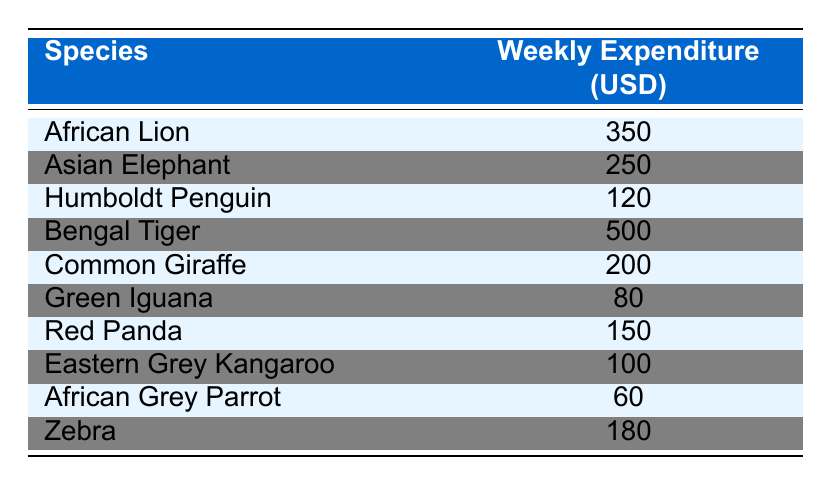What is the weekly expenditure for a Bengal Tiger? The table shows a specific expenditure for each species. Looking at the row for Bengal Tiger, the weekly expenditure is listed as 500 USD.
Answer: 500 USD Which species has the lowest weekly expenditure? To find the lowest expenditure, we can compare the values in the table. The Green Iguana has the lowest amount listed at 80 USD.
Answer: Green Iguana What is the total weekly expenditure for all species combined? To find the total, we sum up the weekly expenditures from all species: 350 + 250 + 120 + 500 + 200 + 80 + 150 + 100 + 60 + 180 = 1990 USD.
Answer: 1990 USD Is the weekly expenditure for an African Grey Parrot greater than 70 USD? The weekly expenditure for an African Grey Parrot is listed as 60 USD, which is less than 70 USD.
Answer: No What is the average weekly expenditure for the exotic species (African Lion, Bengal Tiger, Red Panda, and Humboldt Penguin)? To find the average, first sum the weekly expenditures for these four species (350 + 500 + 150 + 120 = 1120 USD) and then divide by the number of species (4). So, the average is 1120/4 = 280 USD.
Answer: 280 USD How much more does the weekly expenditure of an Asian Elephant exceed that of a Zebra? The weekly expenditure for an Asian Elephant is 250 USD and for a Zebra it is 180 USD. Subtracting these gives 250 - 180 = 70 USD.
Answer: 70 USD Are all species listed in the table requiring more than 50 USD in weekly expenditure? Checking the table reveals that the African Grey Parrot has an expenditure of 60 USD, which is above 50 USD, and so do all other species.
Answer: Yes What is the difference between the highest and lowest weekly expenditures among the species? The highest expenditure is for the Bengal Tiger at 500 USD, and the lowest is for the Green Iguana at 80 USD. The difference is 500 - 80 = 420 USD.
Answer: 420 USD 